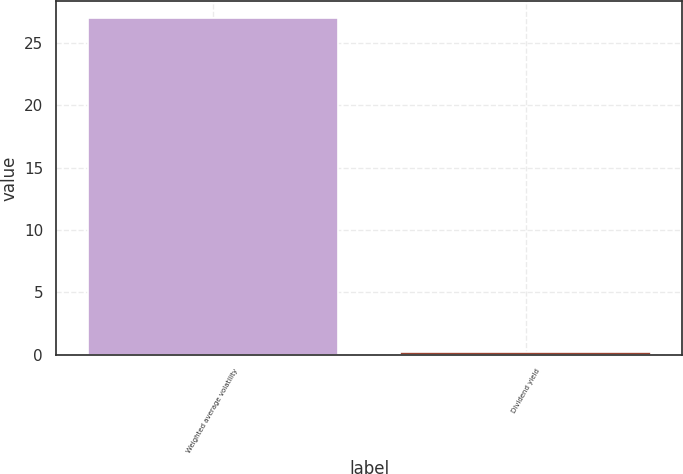<chart> <loc_0><loc_0><loc_500><loc_500><bar_chart><fcel>Weighted average volatility<fcel>Dividend yield<nl><fcel>27<fcel>0.2<nl></chart> 